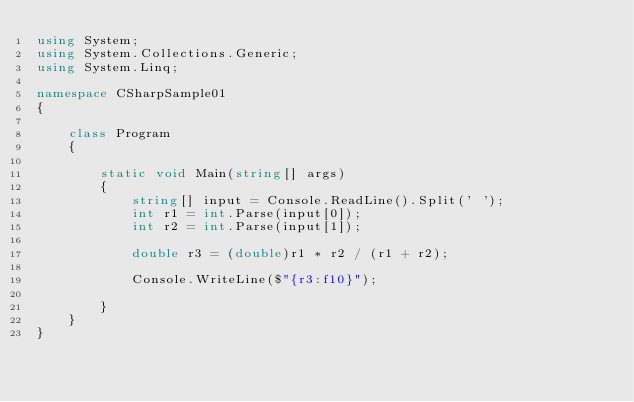Convert code to text. <code><loc_0><loc_0><loc_500><loc_500><_C#_>using System;
using System.Collections.Generic;
using System.Linq;

namespace CSharpSample01
{
    
    class Program
    {
        
        static void Main(string[] args)
        {
            string[] input = Console.ReadLine().Split(' ');
            int r1 = int.Parse(input[0]);
            int r2 = int.Parse(input[1]);

            double r3 = (double)r1 * r2 / (r1 + r2);

            Console.WriteLine($"{r3:f10}");

        }
    }
}
</code> 